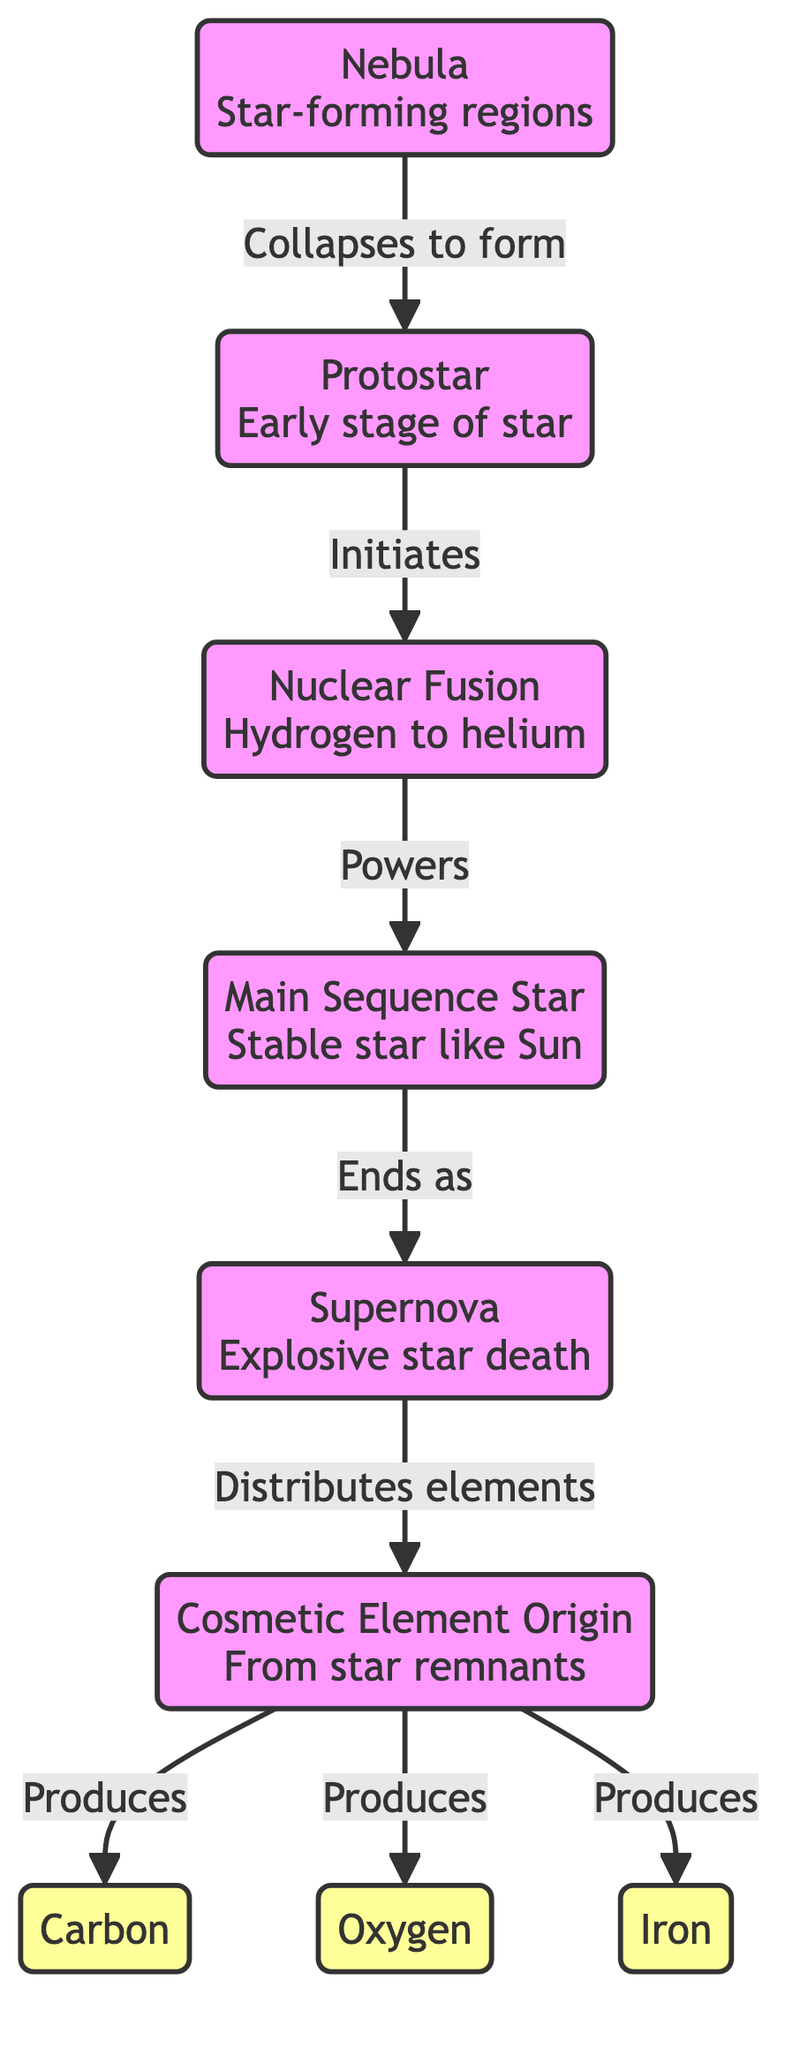What is the first stage of star formation shown in the diagram? The diagram starts with a nebula, which is indicated as the first stage of star formation on the left.
Answer: Nebula What follows after the protostar in star formation? After the protostar, the next step according to the diagram is nuclear fusion, which indicates the initiation of the fusion process in the star's core.
Answer: Nuclear Fusion How many elements are produced from the cosmetic element origin? The diagram indicates three distinct elements (carbon, oxygen, iron) produced from the cosmetic element origin, shown as three separate arrows pointing to each element.
Answer: 3 What type of star is represented at the main sequence? The main sequence star shown in the diagram is described as a stable star like the Sun, which is identified as a characteristic of this stage.
Answer: Stable star like Sun What event occurs after the main sequence star reaches the end of its life cycle? The diagram shows that after the main sequence star ends its life cycle, it results in a supernova, marking the explosive death of the star.
Answer: Supernova What do the remnants of a supernova lead to in terms of cosmetic elements? The diagram illustrates that the remnants of a supernova are distributed, leading to the origin of cosmetic elements, indicating a connection between stellar death and material for cosmetics.
Answer: Cosmetic Element Origin Which element is highlighted as a product of star remnants for cosmetic use? The diagram clearly shows that carbon is one of the elements produced from the remnants of a star, especially in relation to cosmetics.
Answer: Carbon What kind of diagram is this that connects stars and cosmetics? This is an astronomy diagram, specifically focused on star formation and its connection to cosmetic ingredients, showcasing the flow from nebula to cosmetic elements.
Answer: Astronomy Diagram 